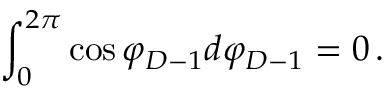Convert formula to latex. <formula><loc_0><loc_0><loc_500><loc_500>\int _ { 0 } ^ { 2 \pi } \cos \varphi _ { D - 1 } d \varphi _ { D - 1 } = 0 \, .</formula> 